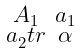Convert formula to latex. <formula><loc_0><loc_0><loc_500><loc_500>\begin{smallmatrix} A _ { 1 } & a _ { 1 } \\ a _ { 2 } ^ { \ } t r & \alpha \end{smallmatrix}</formula> 